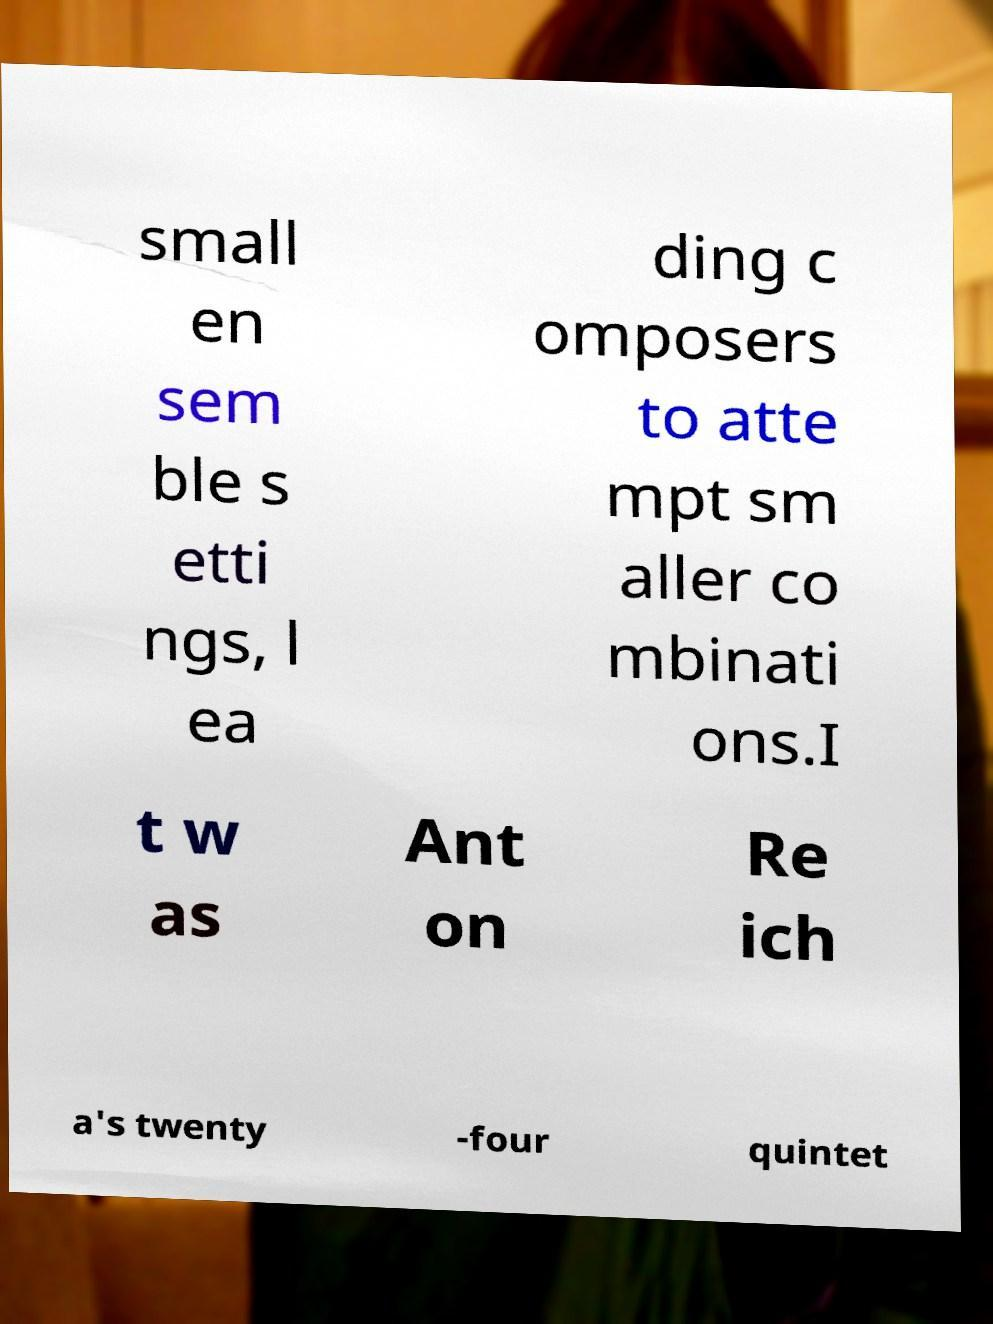Can you read and provide the text displayed in the image?This photo seems to have some interesting text. Can you extract and type it out for me? small en sem ble s etti ngs, l ea ding c omposers to atte mpt sm aller co mbinati ons.I t w as Ant on Re ich a's twenty -four quintet 